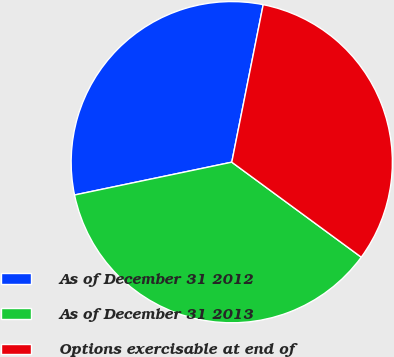Convert chart. <chart><loc_0><loc_0><loc_500><loc_500><pie_chart><fcel>As of December 31 2012<fcel>As of December 31 2013<fcel>Options exercisable at end of<nl><fcel>31.41%<fcel>36.65%<fcel>31.94%<nl></chart> 